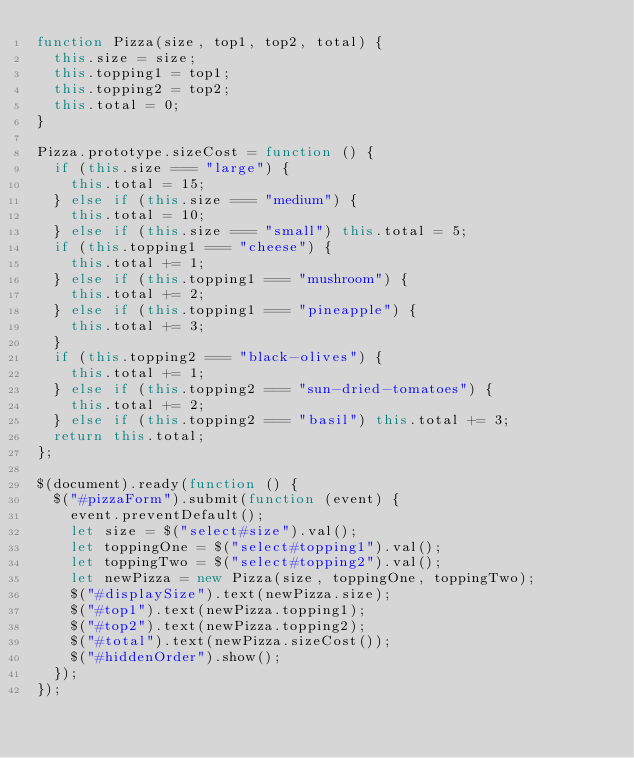<code> <loc_0><loc_0><loc_500><loc_500><_JavaScript_>function Pizza(size, top1, top2, total) {
  this.size = size;
  this.topping1 = top1;
  this.topping2 = top2;
  this.total = 0;
}

Pizza.prototype.sizeCost = function () {
  if (this.size === "large") {
    this.total = 15;
  } else if (this.size === "medium") {
    this.total = 10;
  } else if (this.size === "small") this.total = 5;
  if (this.topping1 === "cheese") {
    this.total += 1;
  } else if (this.topping1 === "mushroom") {
    this.total += 2;
  } else if (this.topping1 === "pineapple") {
    this.total += 3;
  }
  if (this.topping2 === "black-olives") {
    this.total += 1;
  } else if (this.topping2 === "sun-dried-tomatoes") {
    this.total += 2;
  } else if (this.topping2 === "basil") this.total += 3;
  return this.total;
};

$(document).ready(function () {
  $("#pizzaForm").submit(function (event) {
    event.preventDefault();
    let size = $("select#size").val();
    let toppingOne = $("select#topping1").val();
    let toppingTwo = $("select#topping2").val();
    let newPizza = new Pizza(size, toppingOne, toppingTwo);
    $("#displaySize").text(newPizza.size);
    $("#top1").text(newPizza.topping1);
    $("#top2").text(newPizza.topping2);
    $("#total").text(newPizza.sizeCost());
    $("#hiddenOrder").show();
  });
});
</code> 